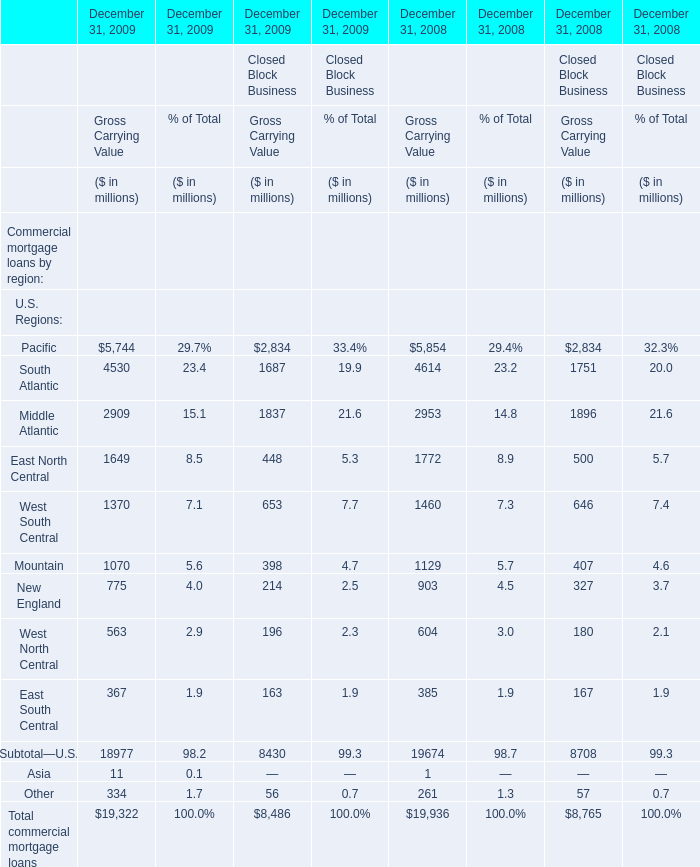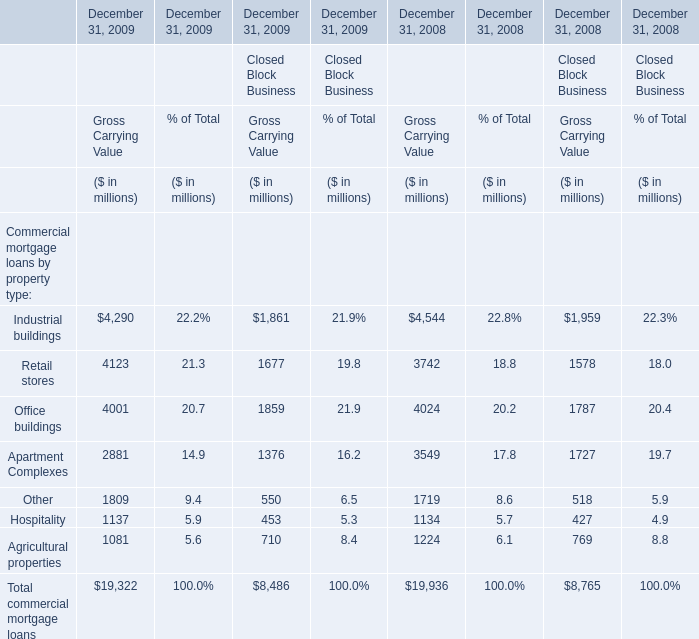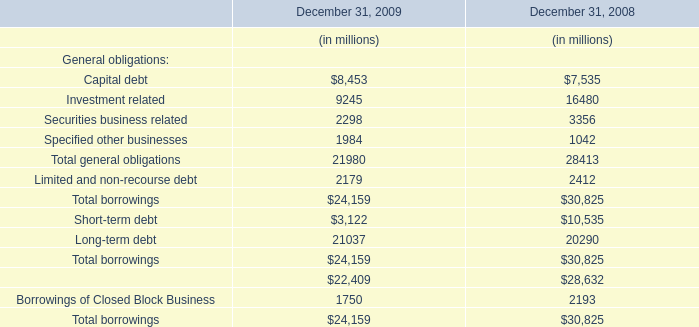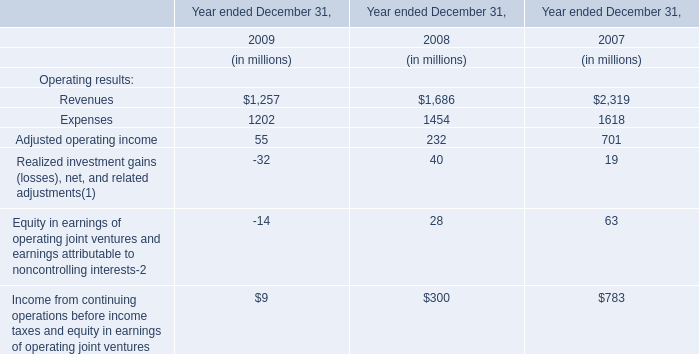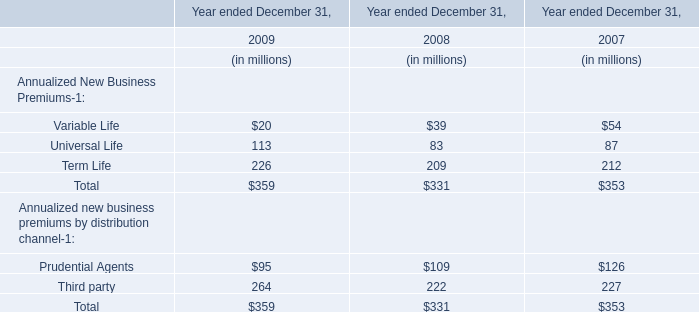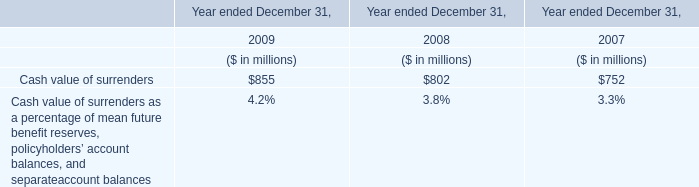Does Industrial buildings keeps increasing each year between 2008 and 2009 for Gross Carrying Value 
Answer: no. 